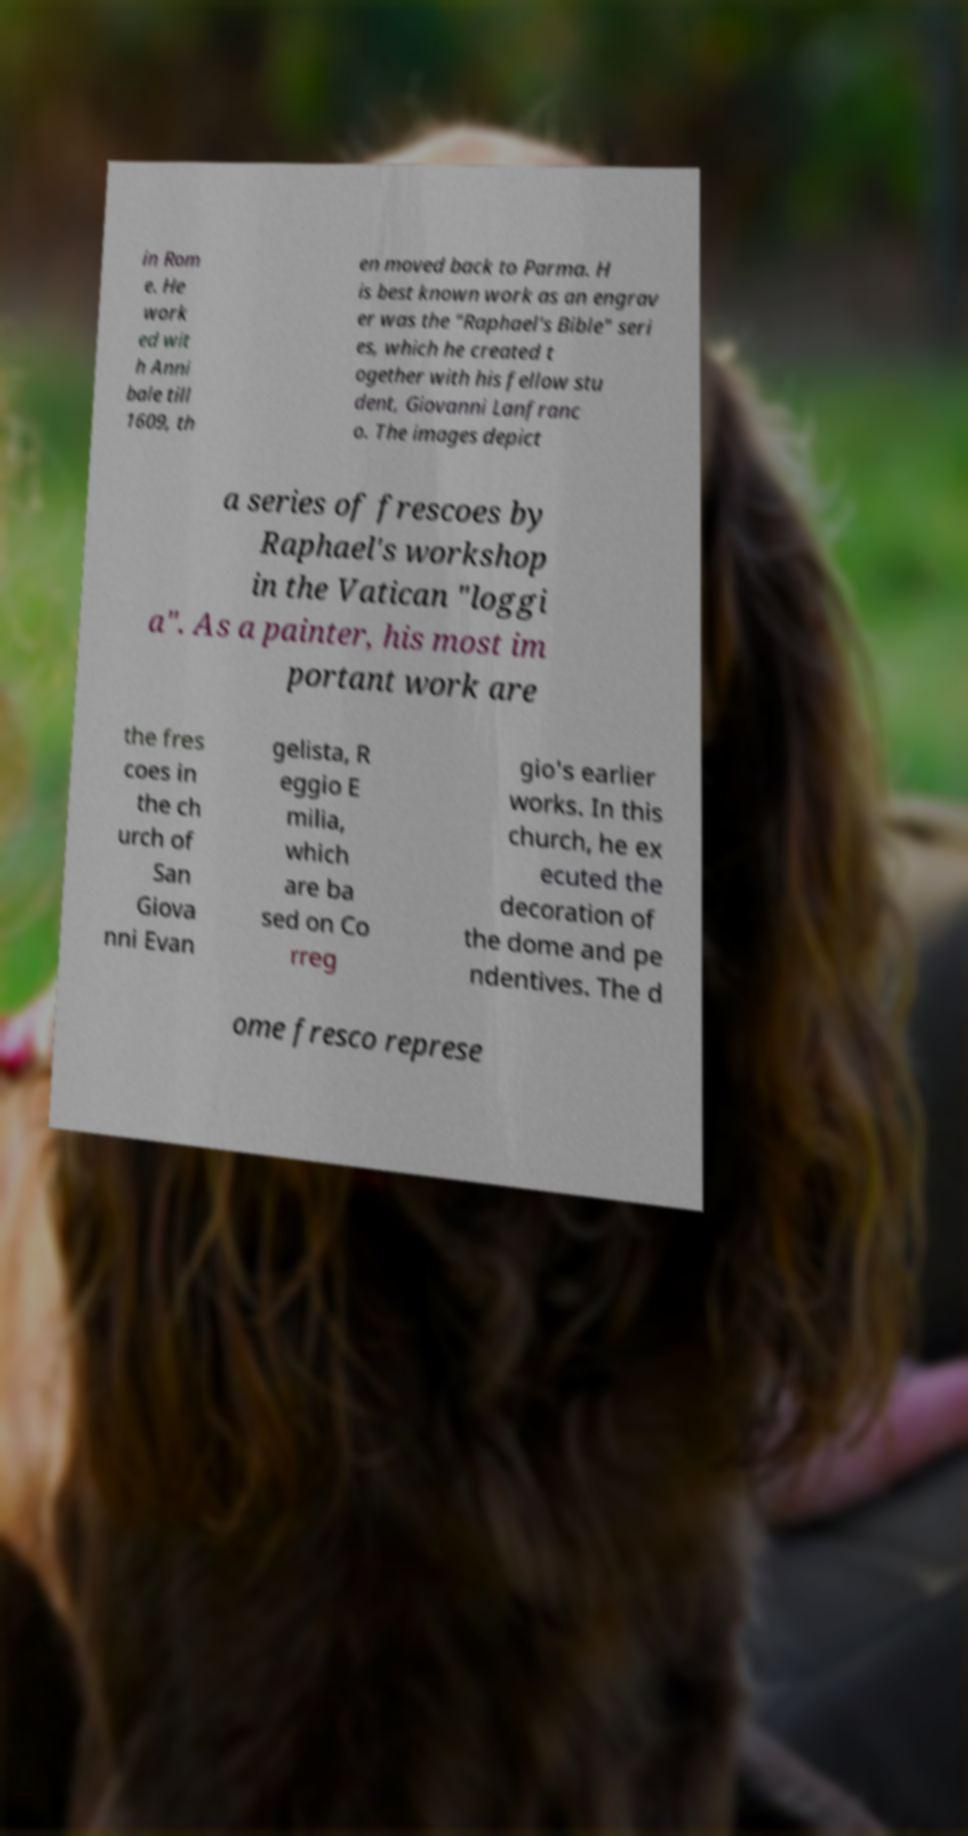Can you accurately transcribe the text from the provided image for me? in Rom e. He work ed wit h Anni bale till 1609, th en moved back to Parma. H is best known work as an engrav er was the "Raphael's Bible" seri es, which he created t ogether with his fellow stu dent, Giovanni Lanfranc o. The images depict a series of frescoes by Raphael's workshop in the Vatican "loggi a". As a painter, his most im portant work are the fres coes in the ch urch of San Giova nni Evan gelista, R eggio E milia, which are ba sed on Co rreg gio's earlier works. In this church, he ex ecuted the decoration of the dome and pe ndentives. The d ome fresco represe 